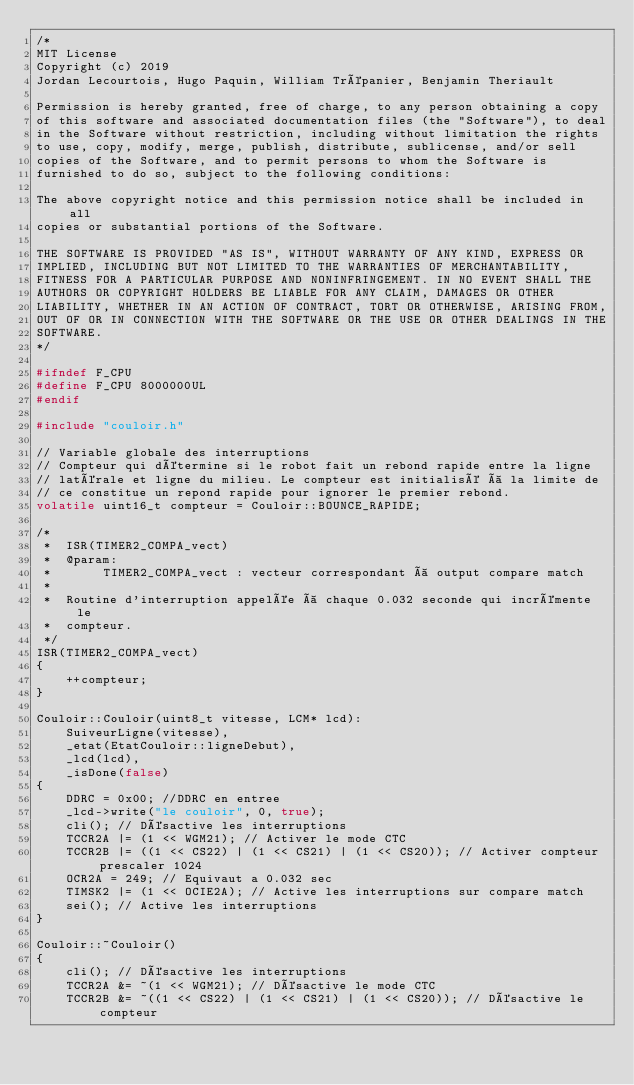Convert code to text. <code><loc_0><loc_0><loc_500><loc_500><_C++_>/*
MIT License
Copyright (c) 2019 
Jordan Lecourtois, Hugo Paquin, William Trépanier, Benjamin Theriault 

Permission is hereby granted, free of charge, to any person obtaining a copy
of this software and associated documentation files (the "Software"), to deal
in the Software without restriction, including without limitation the rights
to use, copy, modify, merge, publish, distribute, sublicense, and/or sell
copies of the Software, and to permit persons to whom the Software is
furnished to do so, subject to the following conditions:

The above copyright notice and this permission notice shall be included in all
copies or substantial portions of the Software.

THE SOFTWARE IS PROVIDED "AS IS", WITHOUT WARRANTY OF ANY KIND, EXPRESS OR
IMPLIED, INCLUDING BUT NOT LIMITED TO THE WARRANTIES OF MERCHANTABILITY,
FITNESS FOR A PARTICULAR PURPOSE AND NONINFRINGEMENT. IN NO EVENT SHALL THE
AUTHORS OR COPYRIGHT HOLDERS BE LIABLE FOR ANY CLAIM, DAMAGES OR OTHER
LIABILITY, WHETHER IN AN ACTION OF CONTRACT, TORT OR OTHERWISE, ARISING FROM,
OUT OF OR IN CONNECTION WITH THE SOFTWARE OR THE USE OR OTHER DEALINGS IN THE
SOFTWARE.
*/

#ifndef F_CPU
#define F_CPU 8000000UL
#endif

#include "couloir.h"

// Variable globale des interruptions
// Compteur qui détermine si le robot fait un rebond rapide entre la ligne
// latérale et ligne du milieu. Le compteur est initialisé à la limite de
// ce constitue un repond rapide pour ignorer le premier rebond.
volatile uint16_t compteur = Couloir::BOUNCE_RAPIDE;

/* 
 *  ISR(TIMER2_COMPA_vect)
 *  @param:
 *       TIMER2_COMPA_vect : vecteur correspondant à output compare match
 * 
 *  Routine d'interruption appelée à chaque 0.032 seconde qui incrémente le
 *  compteur. 
 */
ISR(TIMER2_COMPA_vect)
{
    ++compteur;
}

Couloir::Couloir(uint8_t vitesse, LCM* lcd):
    SuiveurLigne(vitesse),
    _etat(EtatCouloir::ligneDebut),
    _lcd(lcd),
    _isDone(false)
{
    DDRC = 0x00; //DDRC en entree
    _lcd->write("le couloir", 0, true);
    cli(); // Désactive les interruptions
    TCCR2A |= (1 << WGM21); // Activer le mode CTC
    TCCR2B |= ((1 << CS22) | (1 << CS21) | (1 << CS20)); // Activer compteur prescaler 1024
    OCR2A = 249; // Equivaut a 0.032 sec
    TIMSK2 |= (1 << OCIE2A); // Active les interruptions sur compare match
    sei(); // Active les interruptions
}

Couloir::~Couloir()
{
    cli(); // Désactive les interruptions
    TCCR2A &= ~(1 << WGM21); // Désactive le mode CTC
    TCCR2B &= ~((1 << CS22) | (1 << CS21) | (1 << CS20)); // Désactive le compteur</code> 